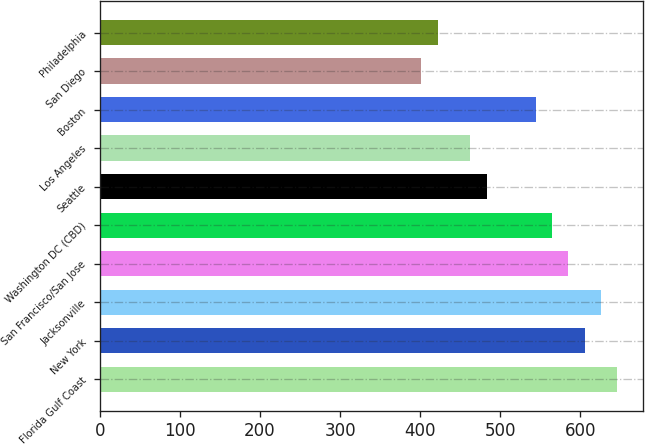Convert chart. <chart><loc_0><loc_0><loc_500><loc_500><bar_chart><fcel>Florida Gulf Coast<fcel>New York<fcel>Jacksonville<fcel>San Francisco/San Jose<fcel>Washington DC (CBD)<fcel>Seattle<fcel>Los Angeles<fcel>Boston<fcel>San Diego<fcel>Philadelphia<nl><fcel>646.27<fcel>605.51<fcel>625.89<fcel>585.13<fcel>564.75<fcel>483.23<fcel>462.85<fcel>544.37<fcel>401.71<fcel>422.09<nl></chart> 